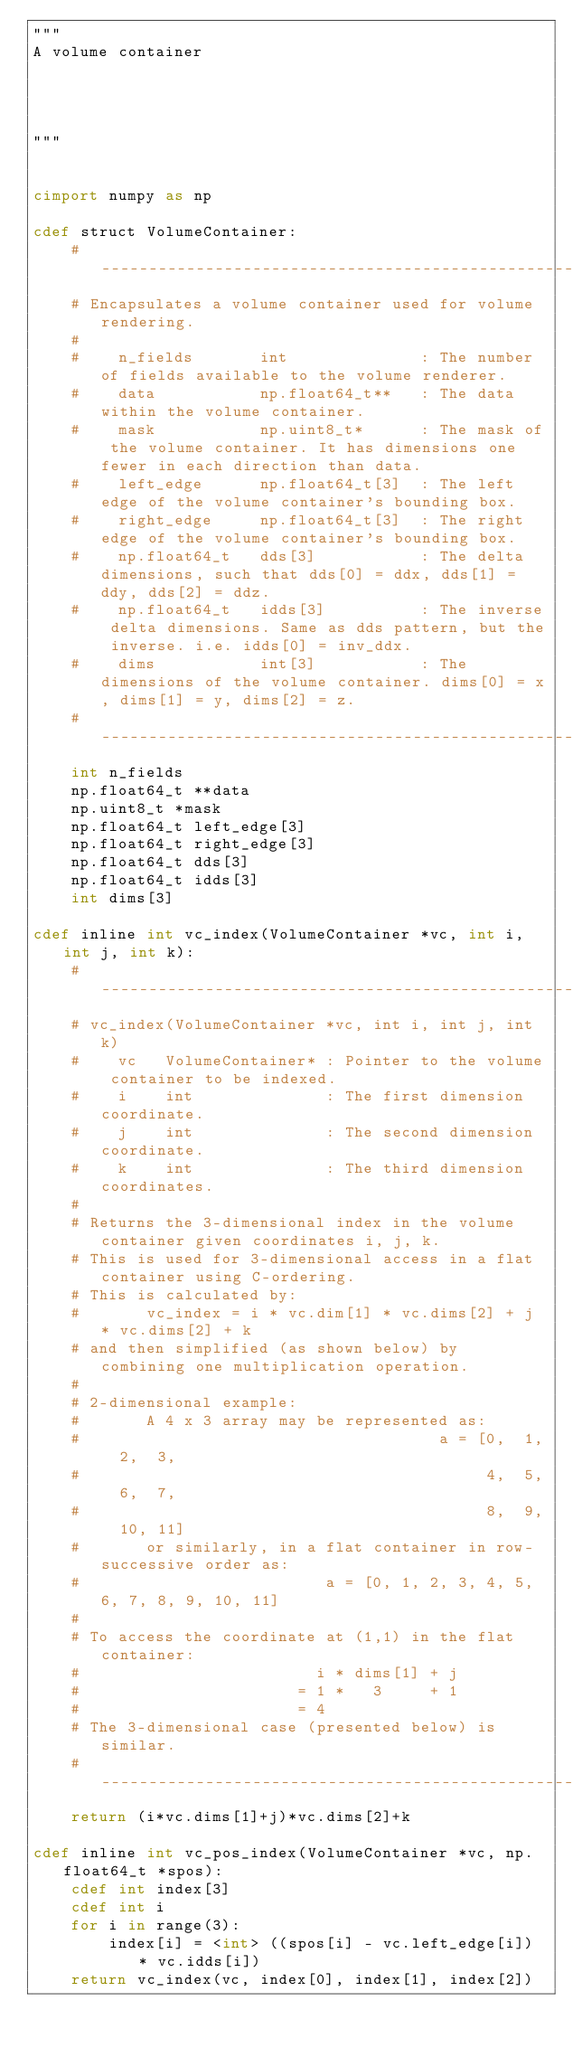Convert code to text. <code><loc_0><loc_0><loc_500><loc_500><_Cython_>"""
A volume container




"""


cimport numpy as np

cdef struct VolumeContainer:
    #-----------------------------------------------------------------------------
    # Encapsulates a volume container used for volume rendering.
    #
    #    n_fields       int              : The number of fields available to the volume renderer.
    #    data           np.float64_t**   : The data within the volume container.
    #    mask           np.uint8_t*      : The mask of the volume container. It has dimensions one fewer in each direction than data.       
    #    left_edge      np.float64_t[3]  : The left edge of the volume container's bounding box.
    #    right_edge     np.float64_t[3]  : The right edge of the volume container's bounding box.
    #    np.float64_t   dds[3]           : The delta dimensions, such that dds[0] = ddx, dds[1] = ddy, dds[2] = ddz.
    #    np.float64_t   idds[3]          : The inverse delta dimensions. Same as dds pattern, but the inverse. i.e. idds[0] = inv_ddx.
    #    dims           int[3]           : The dimensions of the volume container. dims[0] = x, dims[1] = y, dims[2] = z.
    #-----------------------------------------------------------------------------
    int n_fields
    np.float64_t **data
    np.uint8_t *mask
    np.float64_t left_edge[3]
    np.float64_t right_edge[3]
    np.float64_t dds[3]
    np.float64_t idds[3]
    int dims[3]

cdef inline int vc_index(VolumeContainer *vc, int i, int j, int k):
    #-----------------------------------------------------------------------------
    # vc_index(VolumeContainer *vc, int i, int j, int k)
    #    vc   VolumeContainer* : Pointer to the volume container to be indexed.
    #    i    int              : The first dimension coordinate.
    #    j    int              : The second dimension coordinate.
    #    k    int              : The third dimension coordinates.
    #
    # Returns the 3-dimensional index in the volume container given coordinates i, j, k.
    # This is used for 3-dimensional access in a flat container using C-ordering.
    # This is calculated by: 
    #       vc_index = i * vc.dim[1] * vc.dims[2] + j * vc.dims[2] + k
    # and then simplified (as shown below) by combining one multiplication operation.
    #
    # 2-dimensional example:
    #       A 4 x 3 array may be represented as: 
    #                                      a = [0,  1,  2,  3,
    #                                           4,  5,  6,  7,
    #                                           8,  9,  10, 11]
    #       or similarly, in a flat container in row-successive order as:
    #                          a = [0, 1, 2, 3, 4, 5, 6, 7, 8, 9, 10, 11]
    #
    # To access the coordinate at (1,1) in the flat container:
    #                         i * dims[1] + j
    #                       = 1 *   3     + 1
    #                       = 4
    # The 3-dimensional case (presented below) is similar.
    #-----------------------------------------------------------------------------
    return (i*vc.dims[1]+j)*vc.dims[2]+k

cdef inline int vc_pos_index(VolumeContainer *vc, np.float64_t *spos):
    cdef int index[3]
    cdef int i
    for i in range(3):
        index[i] = <int> ((spos[i] - vc.left_edge[i]) * vc.idds[i])
    return vc_index(vc, index[0], index[1], index[2])
</code> 